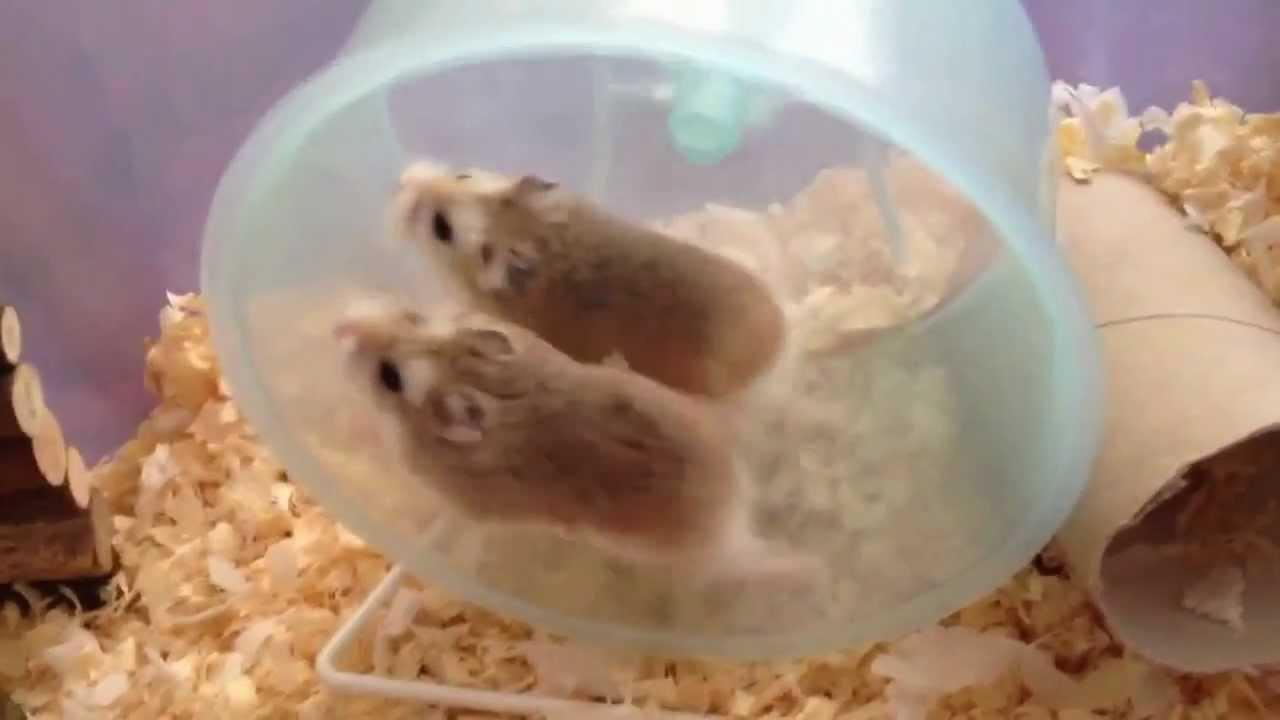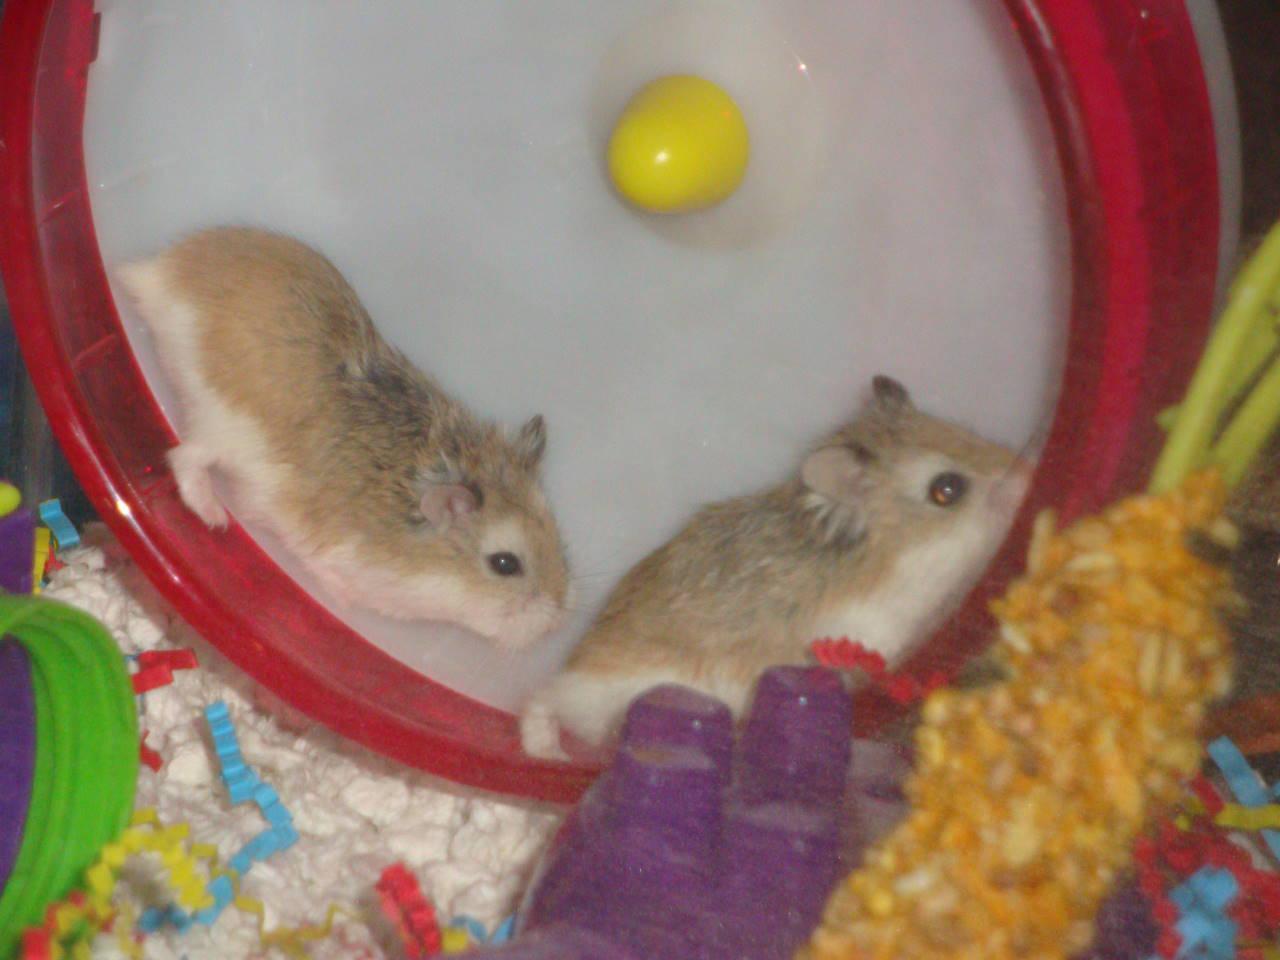The first image is the image on the left, the second image is the image on the right. Examine the images to the left and right. Is the description "The images contain a total of four hamsters that are on a plastic object." accurate? Answer yes or no. Yes. The first image is the image on the left, the second image is the image on the right. For the images shown, is this caption "At least one image shows only one hamster." true? Answer yes or no. No. 